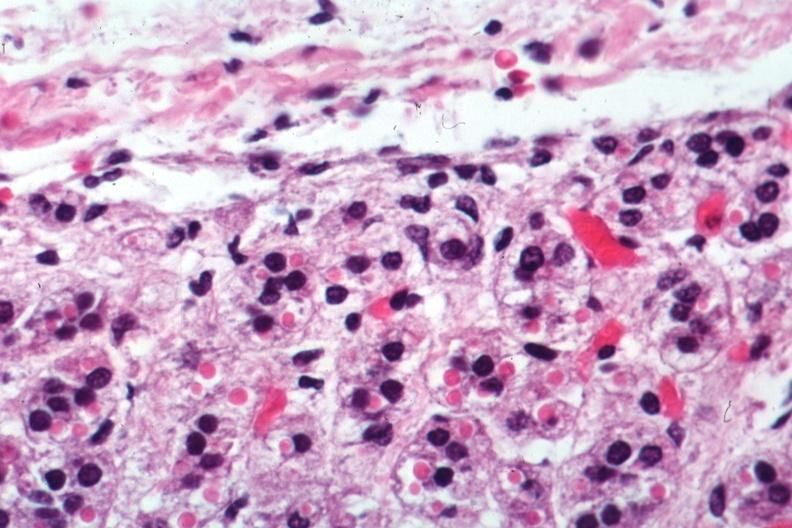s hearts present?
Answer the question using a single word or phrase. No 